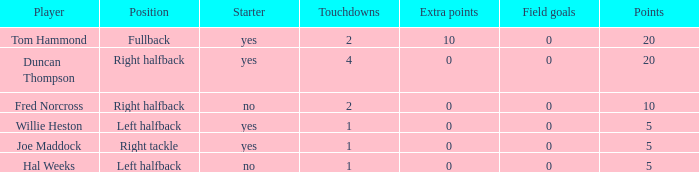What is the maximum field goals when there were over 1 touchdown and 0 additional points? 0.0. 